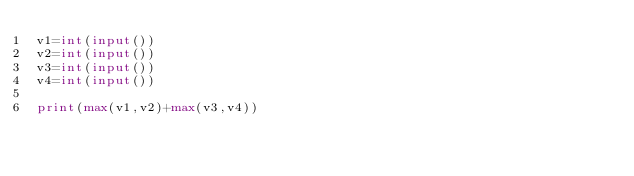Convert code to text. <code><loc_0><loc_0><loc_500><loc_500><_Python_>v1=int(input())
v2=int(input())
v3=int(input())
v4=int(input())

print(max(v1,v2)+max(v3,v4))</code> 